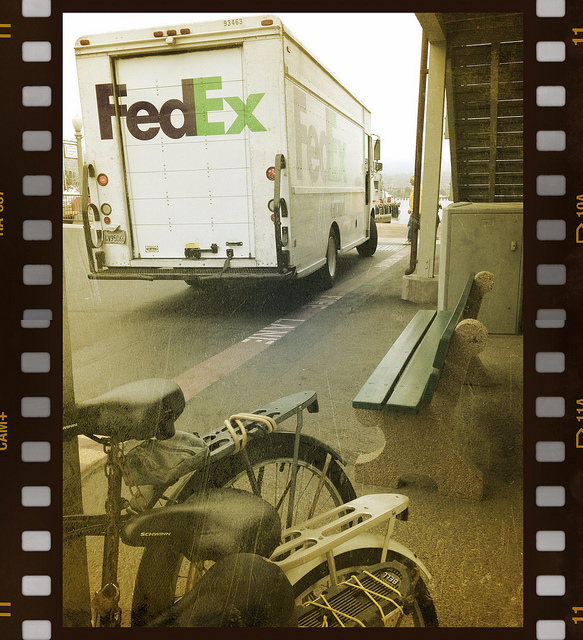Please extract the text content from this image. FedEx FedEx LANE 11 